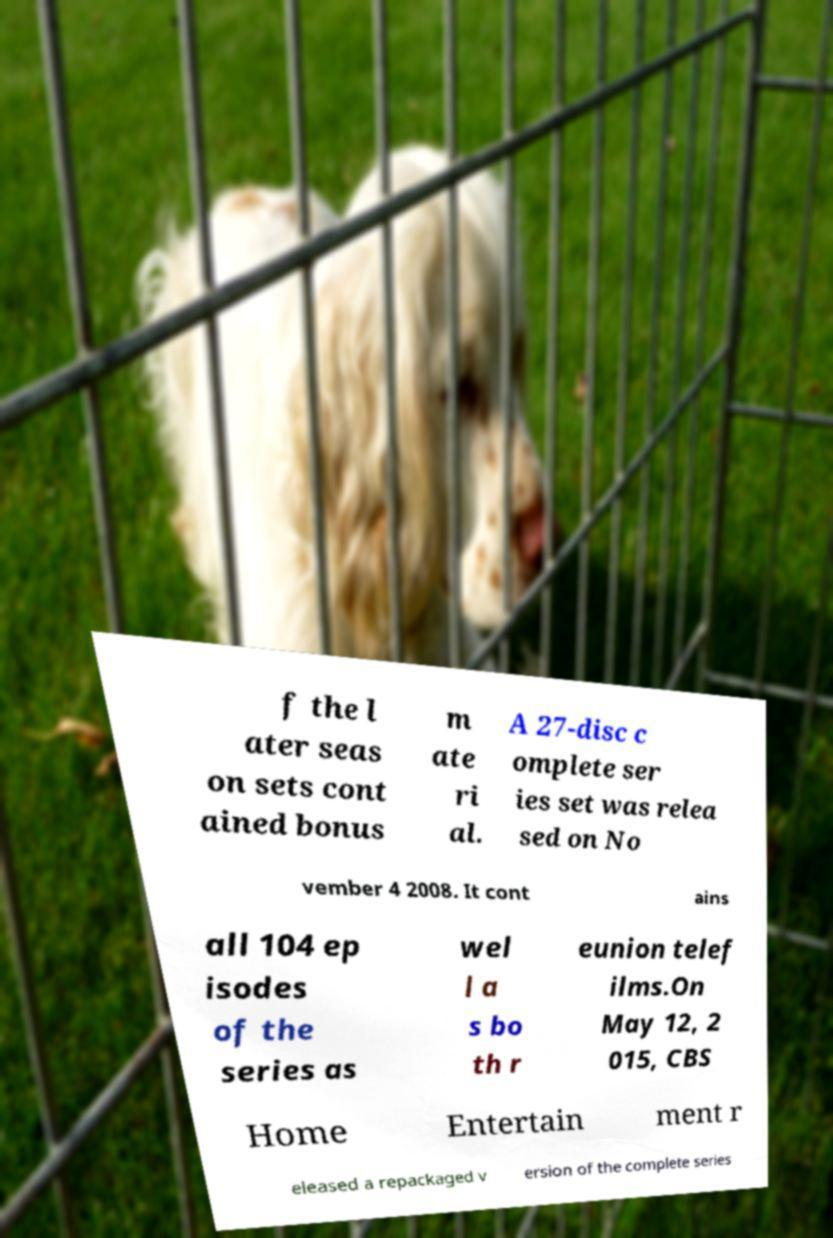Could you extract and type out the text from this image? f the l ater seas on sets cont ained bonus m ate ri al. A 27-disc c omplete ser ies set was relea sed on No vember 4 2008. It cont ains all 104 ep isodes of the series as wel l a s bo th r eunion telef ilms.On May 12, 2 015, CBS Home Entertain ment r eleased a repackaged v ersion of the complete series 